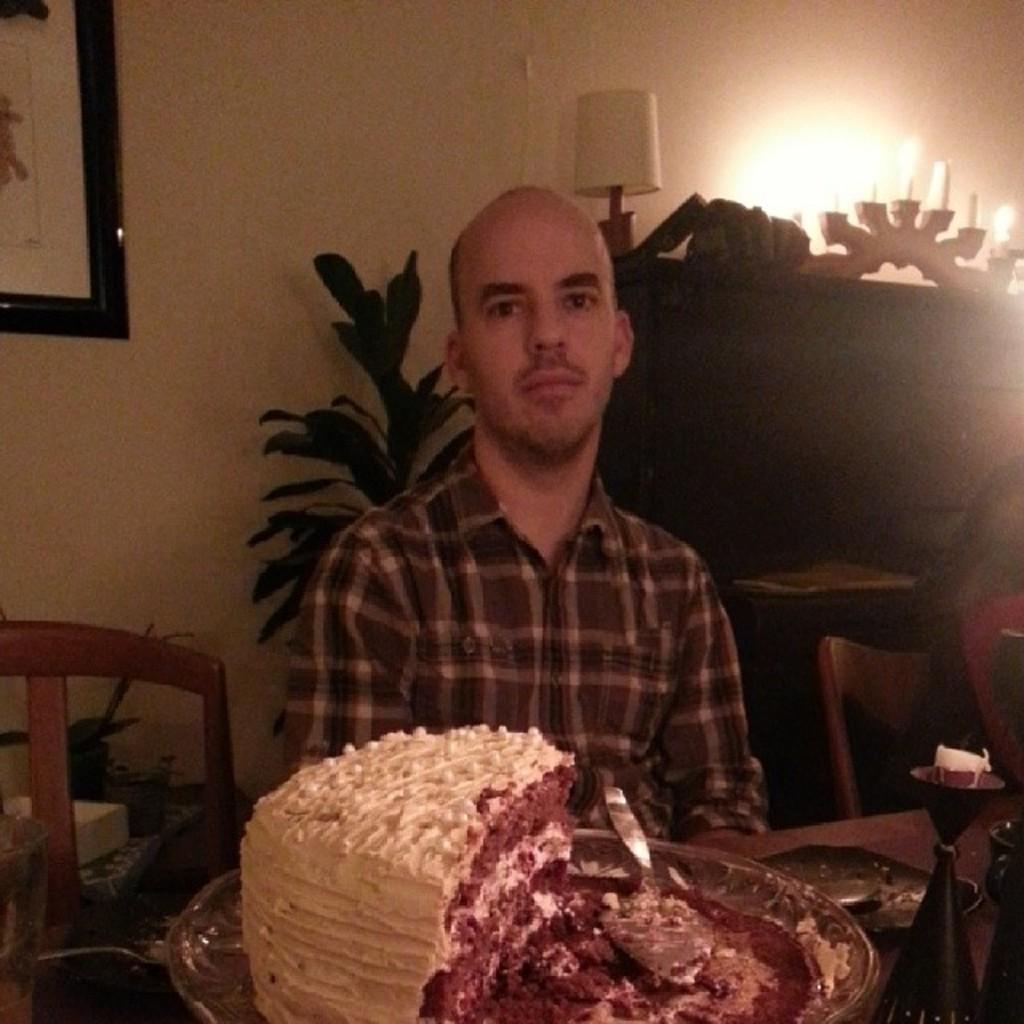What is the man in the image doing? The man is sitting near a table in the image. What is on the table in the image? There is a cake on the table. What can be seen in the background of the image? There is a house plant and a wall with a photo frame in the background of the image. What type of berry is being used to season the cake in the image? There is no berry present in the image, and the cake is not being seasoned with any ingredients. 